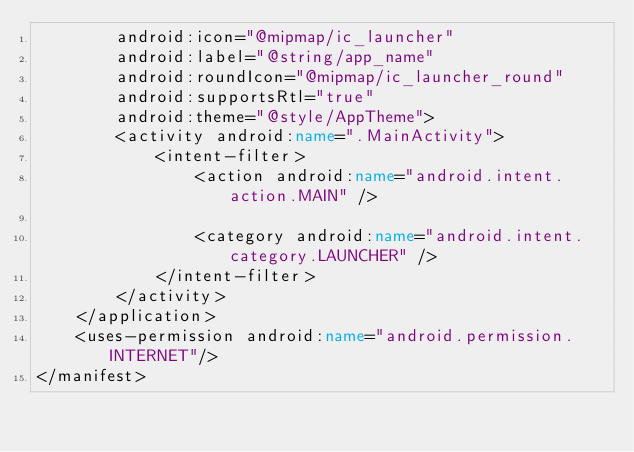Convert code to text. <code><loc_0><loc_0><loc_500><loc_500><_XML_>        android:icon="@mipmap/ic_launcher"
        android:label="@string/app_name"
        android:roundIcon="@mipmap/ic_launcher_round"
        android:supportsRtl="true"
        android:theme="@style/AppTheme">
        <activity android:name=".MainActivity">
            <intent-filter>
                <action android:name="android.intent.action.MAIN" />

                <category android:name="android.intent.category.LAUNCHER" />
            </intent-filter>
        </activity>
    </application>
    <uses-permission android:name="android.permission.INTERNET"/>
</manifest></code> 